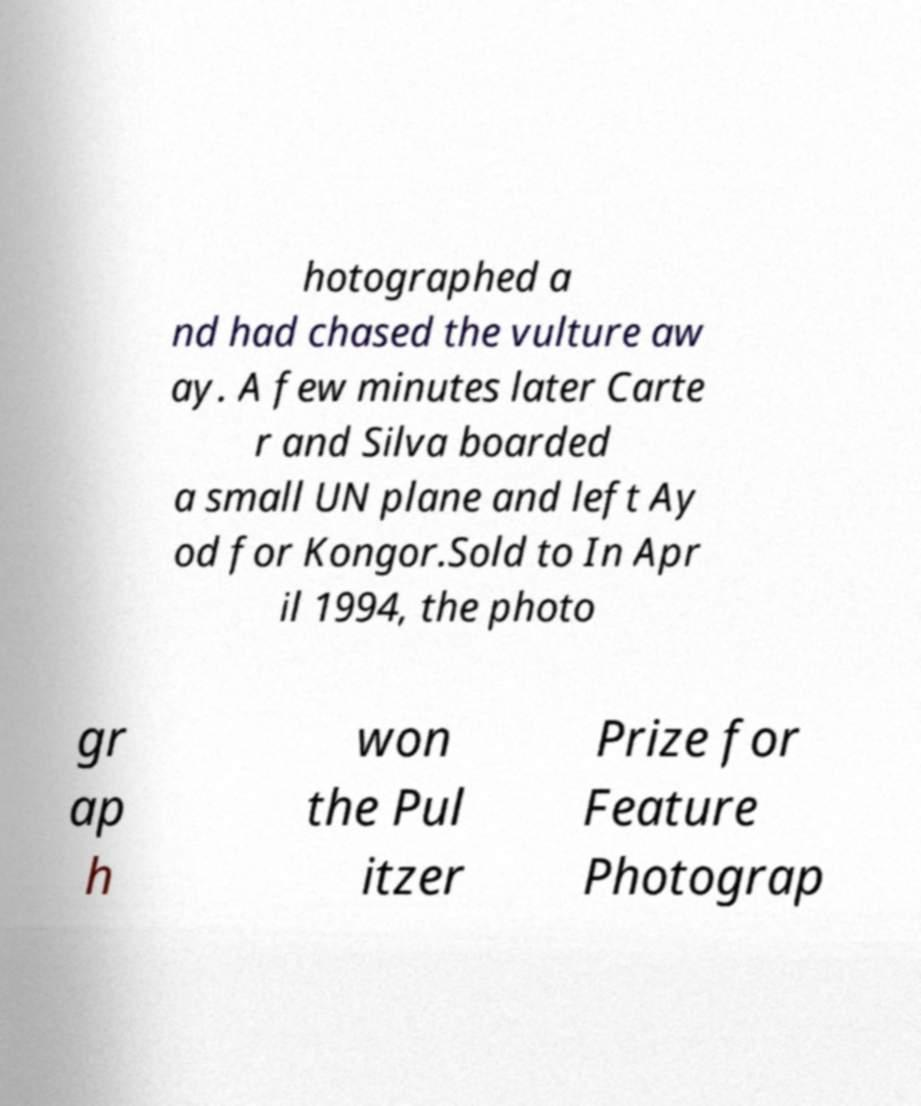There's text embedded in this image that I need extracted. Can you transcribe it verbatim? hotographed a nd had chased the vulture aw ay. A few minutes later Carte r and Silva boarded a small UN plane and left Ay od for Kongor.Sold to In Apr il 1994, the photo gr ap h won the Pul itzer Prize for Feature Photograp 